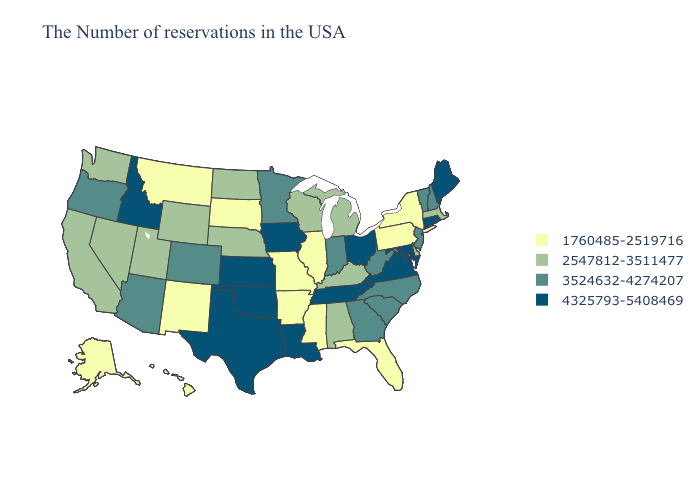What is the value of Louisiana?
Give a very brief answer. 4325793-5408469. Name the states that have a value in the range 4325793-5408469?
Concise answer only. Maine, Rhode Island, Connecticut, Maryland, Virginia, Ohio, Tennessee, Louisiana, Iowa, Kansas, Oklahoma, Texas, Idaho. Name the states that have a value in the range 3524632-4274207?
Answer briefly. New Hampshire, Vermont, New Jersey, North Carolina, South Carolina, West Virginia, Georgia, Indiana, Minnesota, Colorado, Arizona, Oregon. Among the states that border Mississippi , which have the lowest value?
Be succinct. Arkansas. Which states hav the highest value in the West?
Concise answer only. Idaho. Does the first symbol in the legend represent the smallest category?
Concise answer only. Yes. What is the value of Kentucky?
Keep it brief. 2547812-3511477. Does South Carolina have the lowest value in the South?
Answer briefly. No. What is the value of Vermont?
Give a very brief answer. 3524632-4274207. What is the value of Kansas?
Short answer required. 4325793-5408469. Name the states that have a value in the range 3524632-4274207?
Answer briefly. New Hampshire, Vermont, New Jersey, North Carolina, South Carolina, West Virginia, Georgia, Indiana, Minnesota, Colorado, Arizona, Oregon. Name the states that have a value in the range 4325793-5408469?
Be succinct. Maine, Rhode Island, Connecticut, Maryland, Virginia, Ohio, Tennessee, Louisiana, Iowa, Kansas, Oklahoma, Texas, Idaho. What is the value of Alaska?
Be succinct. 1760485-2519716. What is the highest value in the West ?
Concise answer only. 4325793-5408469. Name the states that have a value in the range 1760485-2519716?
Give a very brief answer. New York, Pennsylvania, Florida, Illinois, Mississippi, Missouri, Arkansas, South Dakota, New Mexico, Montana, Alaska, Hawaii. 